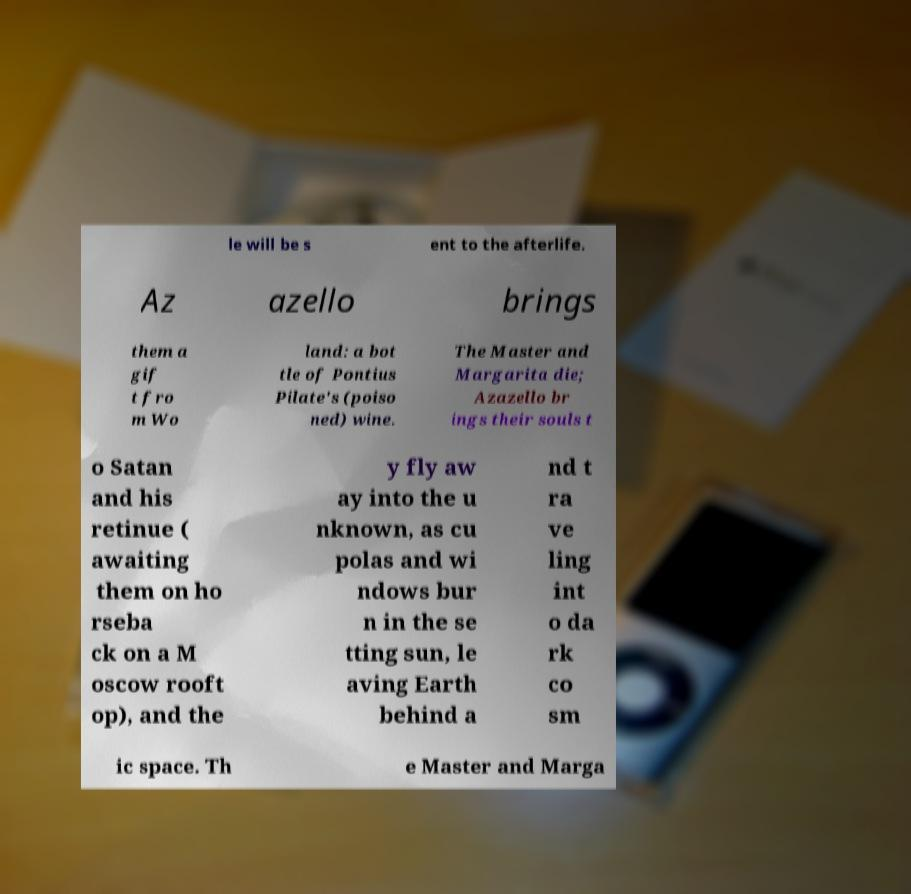Can you accurately transcribe the text from the provided image for me? le will be s ent to the afterlife. Az azello brings them a gif t fro m Wo land: a bot tle of Pontius Pilate's (poiso ned) wine. The Master and Margarita die; Azazello br ings their souls t o Satan and his retinue ( awaiting them on ho rseba ck on a M oscow rooft op), and the y fly aw ay into the u nknown, as cu polas and wi ndows bur n in the se tting sun, le aving Earth behind a nd t ra ve ling int o da rk co sm ic space. Th e Master and Marga 